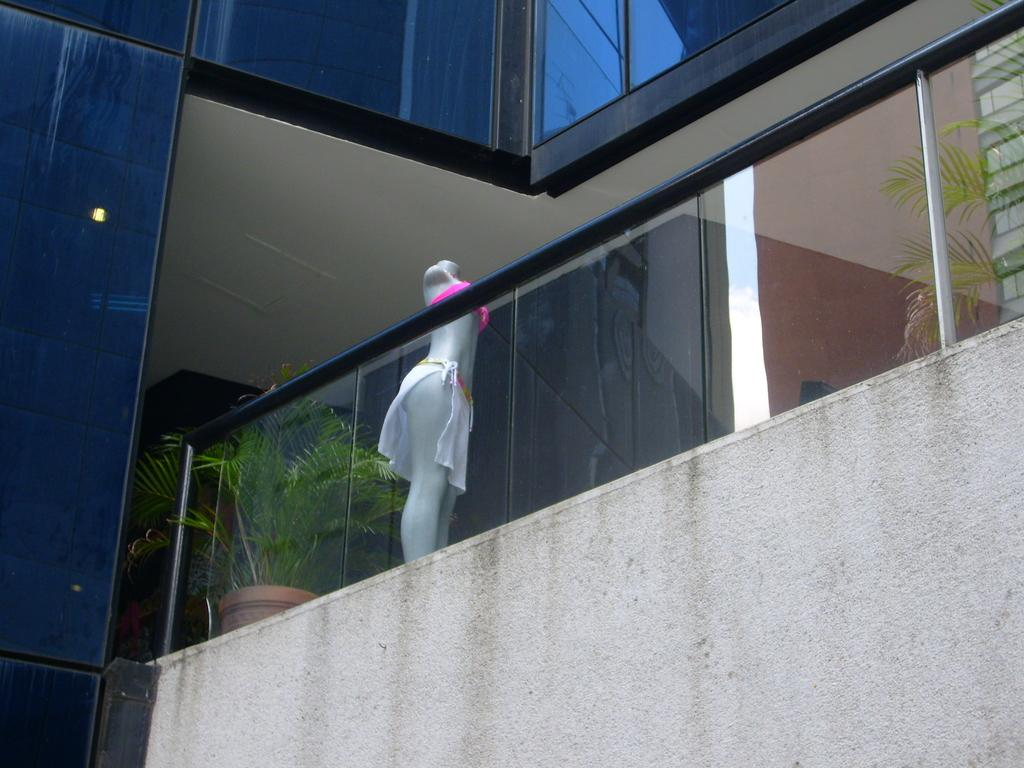What is located in the foreground of the image? There is a wall and a railing in the foreground of the image. What can be seen behind the railing? There are plants and a mannequin visible behind the railing. What type of structure is visible in the background of the image? There is a building with a wall visible in the image. What type of flame can be seen coming from the mannequin's hand in the image? There is no flame present in the image; the mannequin does not have any visible fire or heat source. What song is the mannequin singing in the image? Mannequins are inanimate objects and cannot sing songs, so this question cannot be answered. 